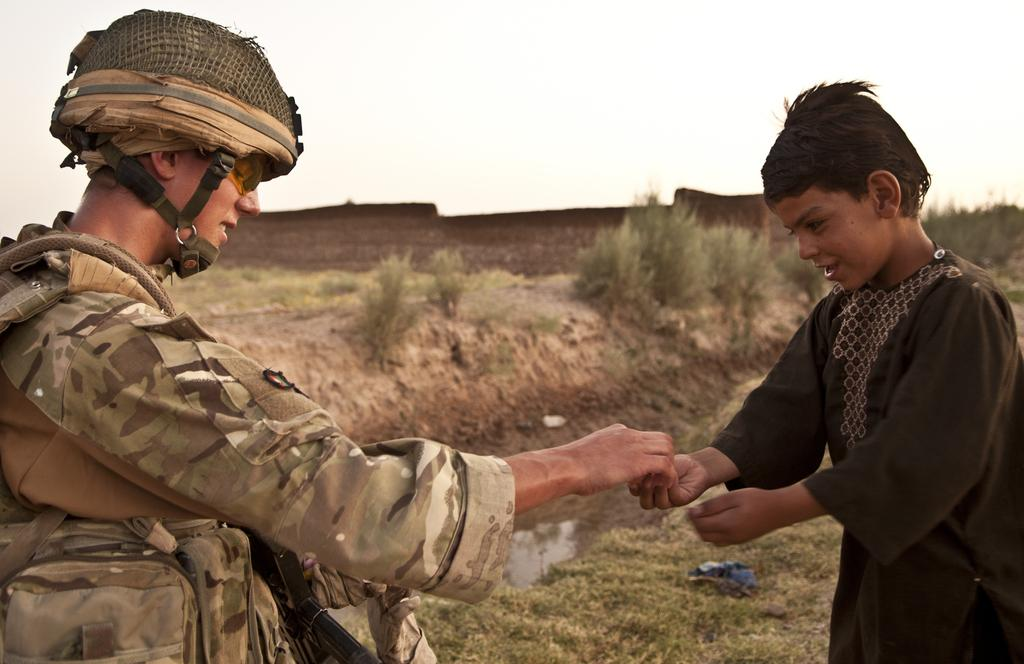How many people are in the image? There are people in the image, but the exact number is not specified. What type of surface is visible in the image? There is ground visible in the image. What is present on the ground in the image? There are objects on the ground in the image. What type of vegetation is visible in the image? There is grass in the image, and there are also plants present. What natural element is visible in the image? There is water in the image. What type of structure is visible in the image? There is a wall in the image. What part of the natural environment is visible in the image? The sky is visible in the image. What type of temper does the quarter have in the image? There is no quarter present in the image, and therefore no temper can be attributed to it. 